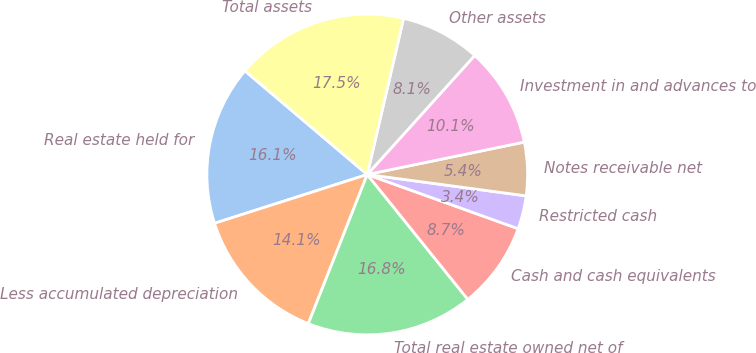Convert chart. <chart><loc_0><loc_0><loc_500><loc_500><pie_chart><fcel>Real estate held for<fcel>Less accumulated depreciation<fcel>Total real estate owned net of<fcel>Cash and cash equivalents<fcel>Restricted cash<fcel>Notes receivable net<fcel>Investment in and advances to<fcel>Other assets<fcel>Total assets<nl><fcel>16.11%<fcel>14.09%<fcel>16.78%<fcel>8.72%<fcel>3.36%<fcel>5.37%<fcel>10.07%<fcel>8.05%<fcel>17.45%<nl></chart> 